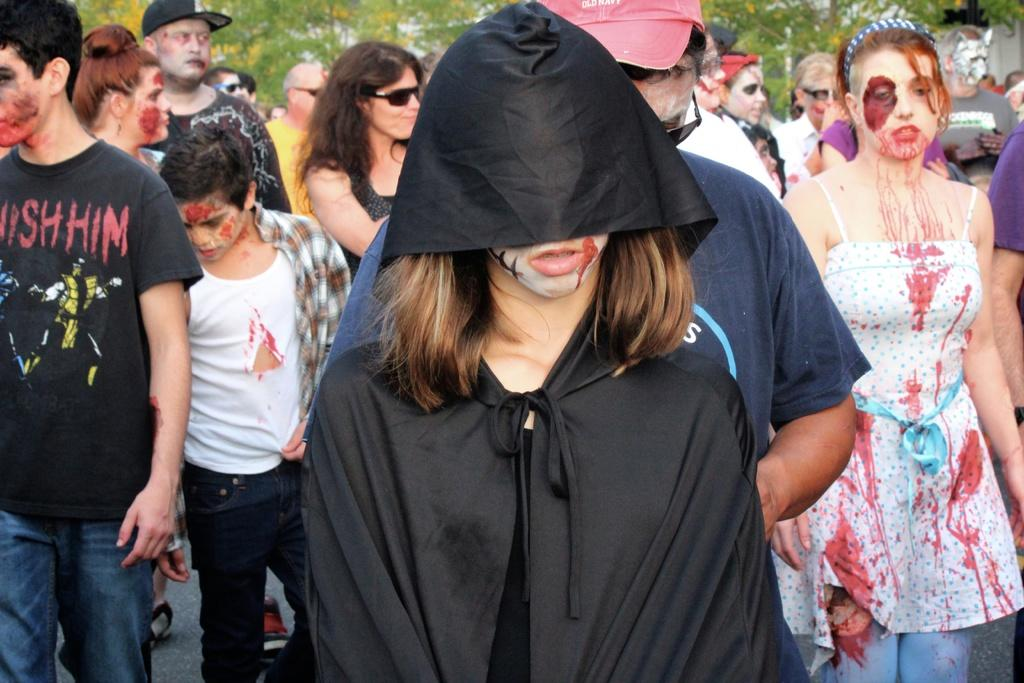What can be seen in the image? There are persons standing in the image. What are the persons wearing? The persons are wearing fancy dress. What can be seen in the background of the image? There are trees in the background of the image. How many ducks are visible in the image? There are no ducks present in the image. What type of worm can be seen crawling on the person's shoulder in the image? There is no worm visible in the image. 